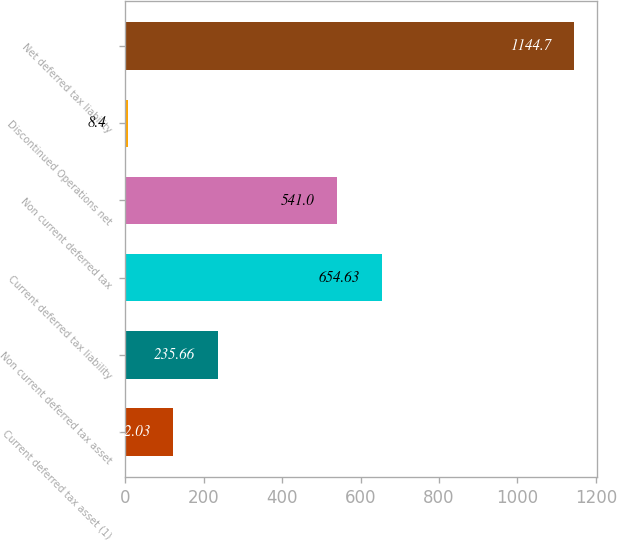Convert chart. <chart><loc_0><loc_0><loc_500><loc_500><bar_chart><fcel>Current deferred tax asset (1)<fcel>Non current deferred tax asset<fcel>Current deferred tax liability<fcel>Non current deferred tax<fcel>Discontinued Operations net<fcel>Net deferred tax liability<nl><fcel>122.03<fcel>235.66<fcel>654.63<fcel>541<fcel>8.4<fcel>1144.7<nl></chart> 